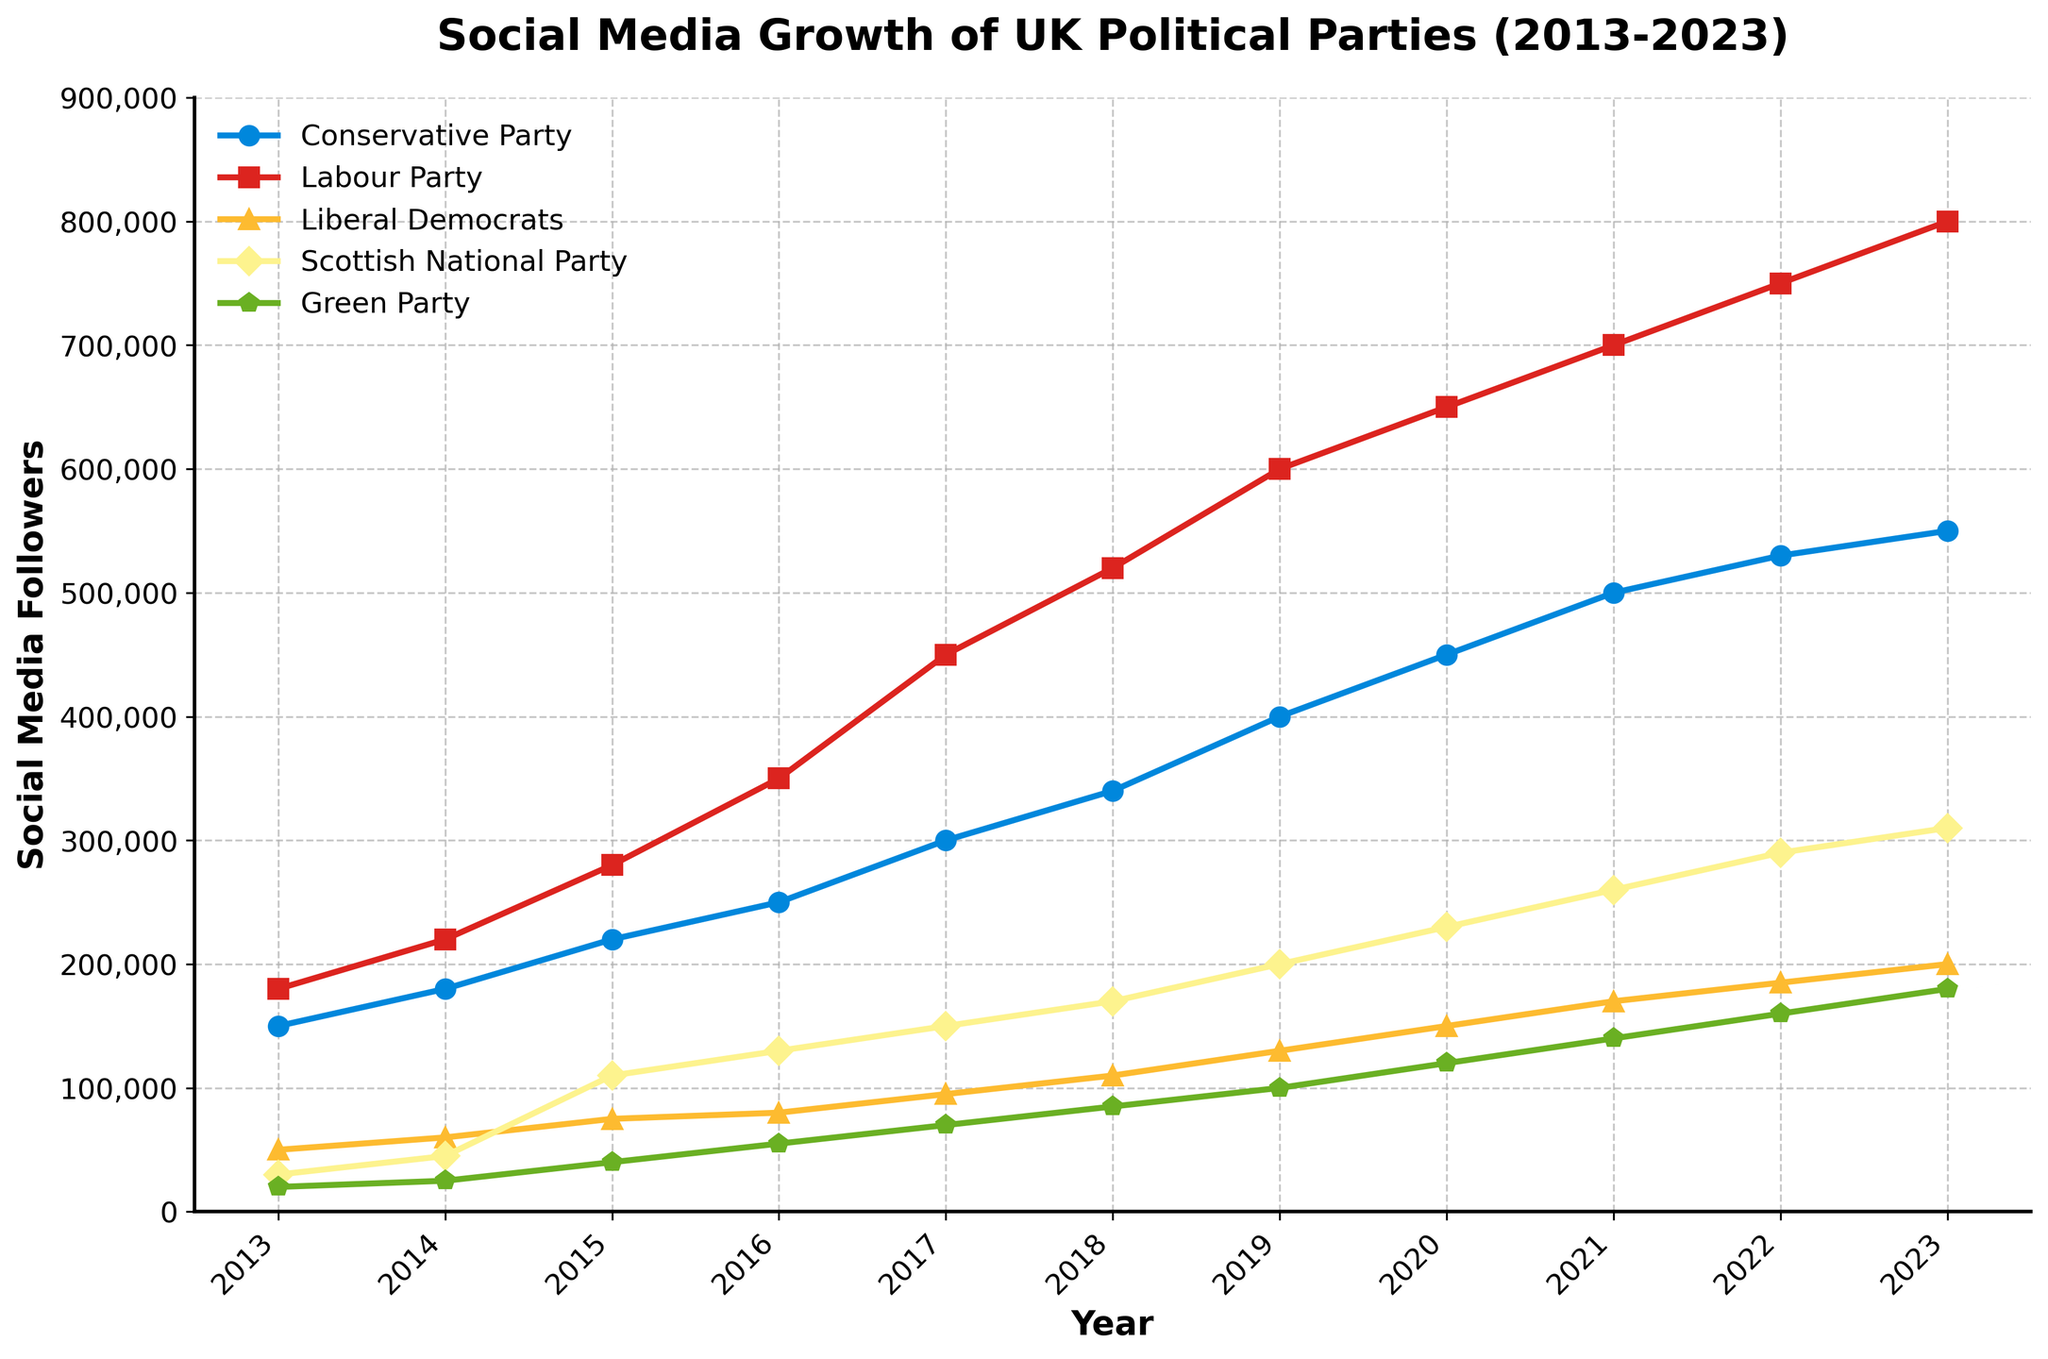What trend do we observe in the social media followers of the Labour Party between 2013 and 2023? The chart shows a steady increase in the Labour Party's social media followers from 180,000 in 2013 to 800,000 in 2023. This consistent upward trend indicates growing online support or engagement with the party over the decade.
Answer: Increasing trend Which party had the highest number of social media followers in 2023? By looking at the end of each line corresponding to 2023, it is clear that the Labour Party had the highest number of social media followers, reaching 800,000 followers.
Answer: Labour Party Compare the follower growth between the Conservative Party and the Green Party from 2013 to 2023. The Conservative Party started with 150,000 followers in 2013 and increased to 550,000 by 2023, gaining 400,000 followers. In contrast, the Green Party started with 20,000 followers and increased to 180,000 in 2023, gaining 160,000 followers. The Conservative Party had a larger follower growth compared to the Green Party, although both showed significant increases.
Answer: Conservative Party had larger growth Between which years did the Scottish National Party see the most significant increase in followers? Observing the slope of the Scottish National Party's line, the most significant increase appears to occur between 2014 and 2015. Followers grew from 45,000 in 2014 to 110,000 in 2015, an increase of 65,000 followers.
Answer: 2014-2015 What is the average number of social media followers for the Liberal Democrats over the decade? The sum of the Liberal Democrats' followers over the years is 50,000 (2013) + 60,000 (2014) + 75,000 (2015) + 80,000 (2016) + 95,000 (2017) + 110,000 (2018) + 130,000 (2019) + 150,000 (2020) + 170,000 (2021) + 185,000 (2022) + 200,000 (2023) = 1,305,000. Dividing by the 11 years gives an average of approximately 118,636 followers.
Answer: Approximately 118,636 Which party showed the least growth in social media followers between 2013 and 2023? By comparing the final 2023 value to the initial 2013 value for each party, the Green Party had the least growth, starting with 20,000 followers in 2013 and ending with 180,000 in 2023, a growth of 160,000 followers.
Answer: Green Party How did the follower count of the Conservative Party compare to the Labour Party in 2017? In 2017, the Labour Party had 450,000 followers, whereas the Conservative Party had 300,000 followers. The Labour Party had 150,000 more followers than the Conservative Party.
Answer: Labour Party had 150,000 more What was the follower count for the Scottish National Party in 2021 compared to the Conservative Party in 2013? The Scottish National Party had 260,000 followers in 2021, while the Conservative Party had 150,000 followers in 2013.
Answer: SNP had 260,000, Conservative had 150,000 Between 2018 and 2020, which party had the greatest percentage increase in followers? The Labour Party increased from 520,000 to 650,000, approximately 25% increase. The Conservative Party increased from 340,000 to 450,000, approximately 32% increase. The Liberal Democrats increased from 110,000 to 150,000, approximately 36% increase. SNP increased from 170,000 to 230,000, approximately 35% increase. The Green Party increased from 85,000 to 120,000, approximately 41% increase. So, the Green Party had the greatest percentage increase.
Answer: Green Party 